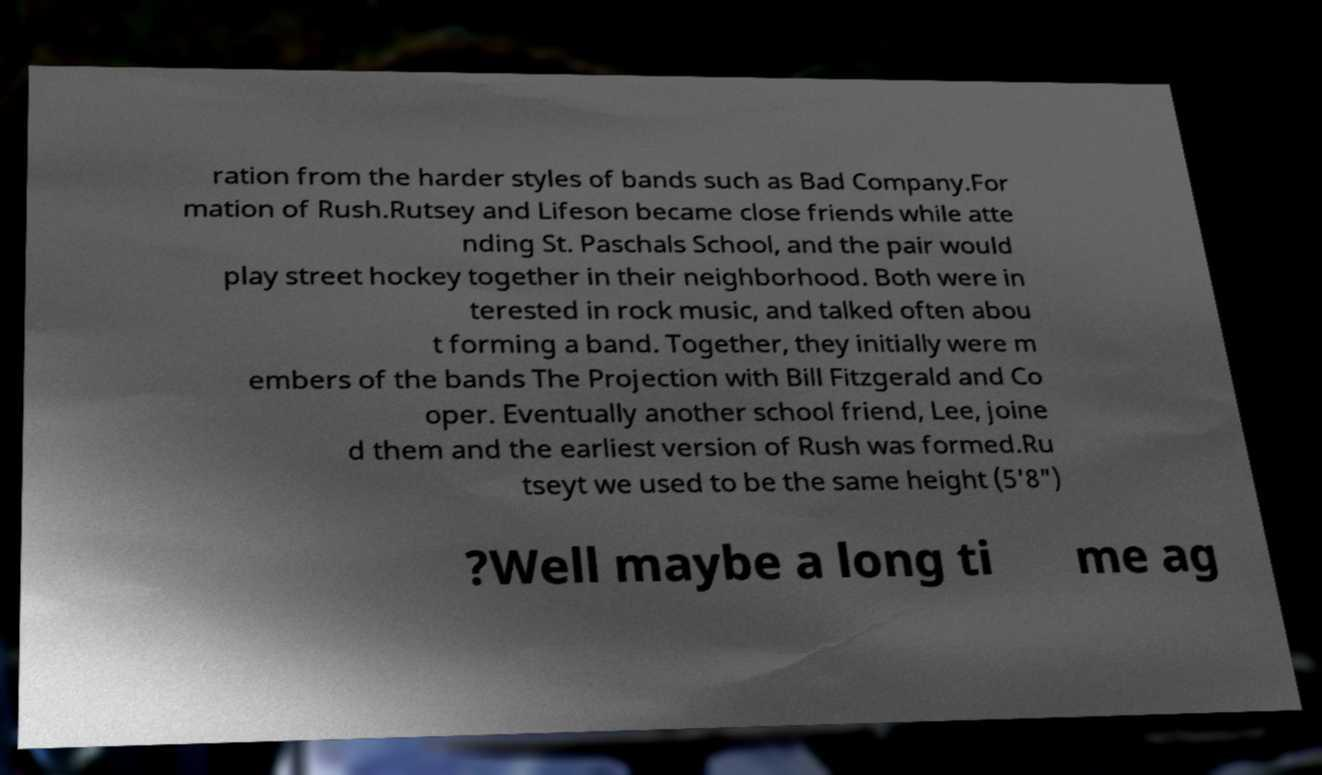Can you accurately transcribe the text from the provided image for me? ration from the harder styles of bands such as Bad Company.For mation of Rush.Rutsey and Lifeson became close friends while atte nding St. Paschals School, and the pair would play street hockey together in their neighborhood. Both were in terested in rock music, and talked often abou t forming a band. Together, they initially were m embers of the bands The Projection with Bill Fitzgerald and Co oper. Eventually another school friend, Lee, joine d them and the earliest version of Rush was formed.Ru tseyt we used to be the same height (5'8") ?Well maybe a long ti me ag 